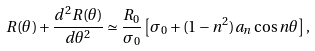Convert formula to latex. <formula><loc_0><loc_0><loc_500><loc_500>R ( \theta ) + \frac { d ^ { 2 } R ( \theta ) } { d \theta ^ { 2 } } \simeq \frac { R _ { 0 } } { \sigma _ { 0 } } \left [ \sigma _ { 0 } + ( 1 - n ^ { 2 } ) a _ { n } \cos n \theta \right ] ,</formula> 